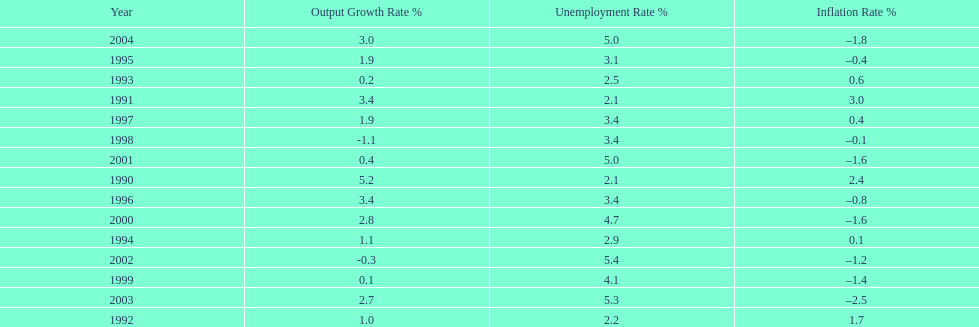What year had the highest unemployment rate? 2002. 